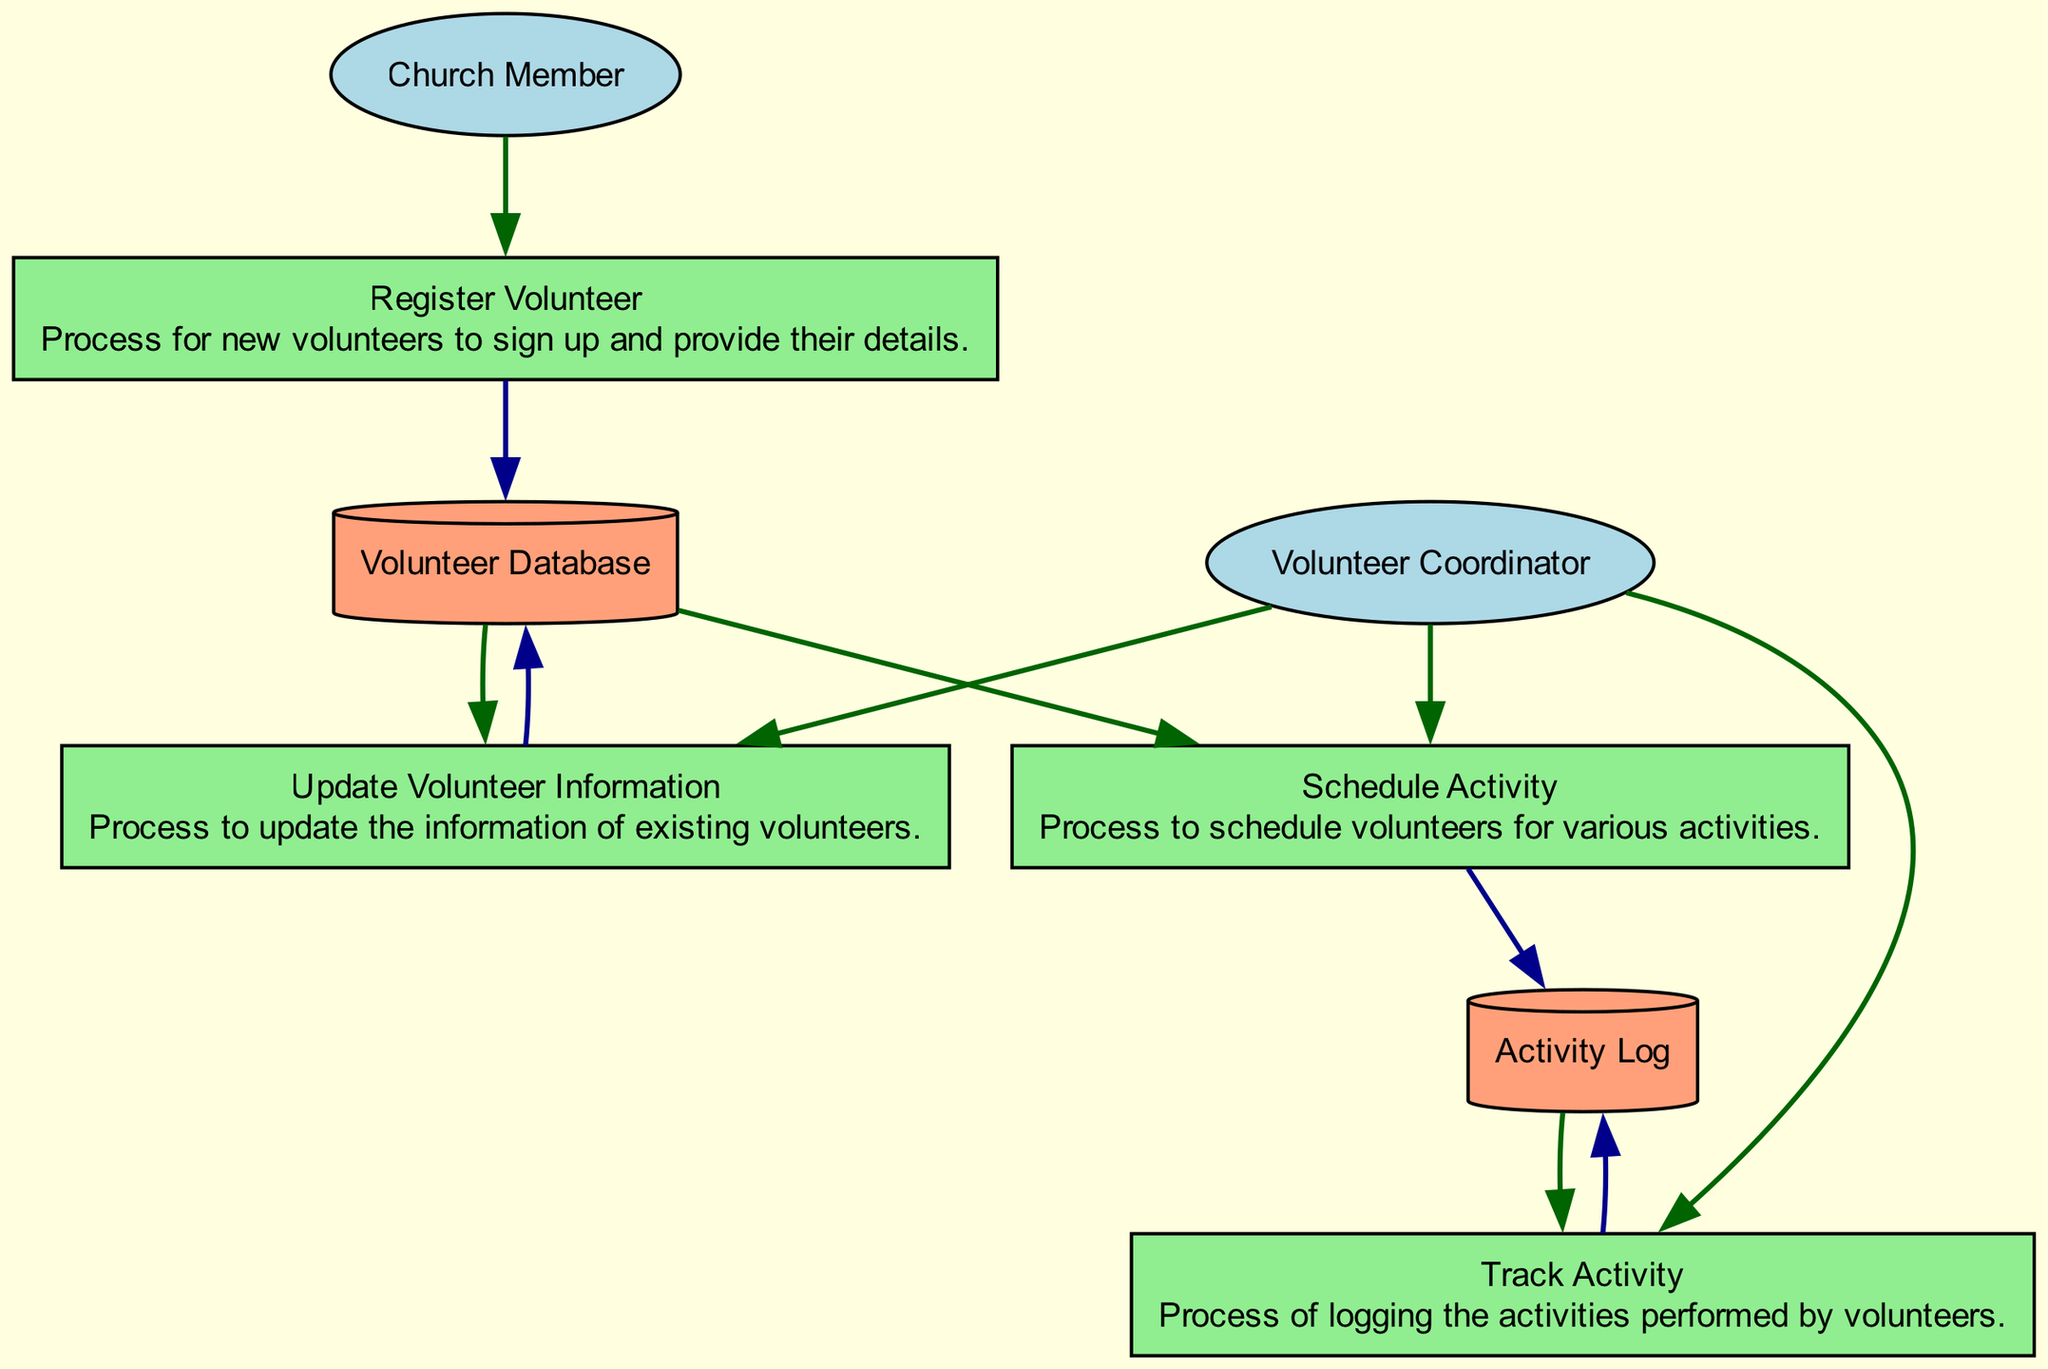What is the input for the "Register Volunteer" process? The input for the "Register Volunteer" process is "Church Member," which indicates that information from a church member is required to initiate the volunteer registration.
Answer: Church Member Which process uses the "Volunteer Database" as an output? The process that uses the "Volunteer Database" as an output is "Update Volunteer Information," as it signifies that the existing volunteer information will be updated and stored back in the database.
Answer: Update Volunteer Information How many external entities are depicted in the diagram? The diagram shows two external entities, namely "Church Member" and "Volunteer Coordinator," both playing significant roles in the volunteer scheduling and activity tracking process.
Answer: Two What action does the "Volunteer Coordinator" perform related to the "Activity Log"? The "Volunteer Coordinator" is involved in the "Track Activity" process, which means they log or document the activities performed by volunteers into the Activity Log.
Answer: Track Activity What does the "Activity Log" store? The "Activity Log" stores records of activities performed by the volunteers, which is crucial for monitoring volunteer engagement and contributions over time.
Answer: Records of activities Which process involves both the "Volunteer Coordinator" and the "Volunteer Database"? The process that involves both the "Volunteer Coordinator" and the "Volunteer Database" is "Schedule Activity," where the coordinator schedules activities based on the volunteers' availability stored in the database.
Answer: Schedule Activity What type of data store is the "Volunteer Database"? The "Volunteer Database" is categorized as a cylinder type data store, which signifies that it holds detailed information about volunteers, including contact details and availability.
Answer: Cylinder How does information flow from "Church Member" to "Volunteer Database"? The flow starts with the "Church Member" providing their details, which then passes through the "Register Volunteer" process, resulting in the information being entered into the "Volunteer Database."
Answer: Register Volunteer Which process updates the information stored in the "Volunteer Database"? The process that updates the information in the "Volunteer Database" is "Update Volunteer Information," as it explicitly describes the change of existing volunteer details within the database.
Answer: Update Volunteer Information 